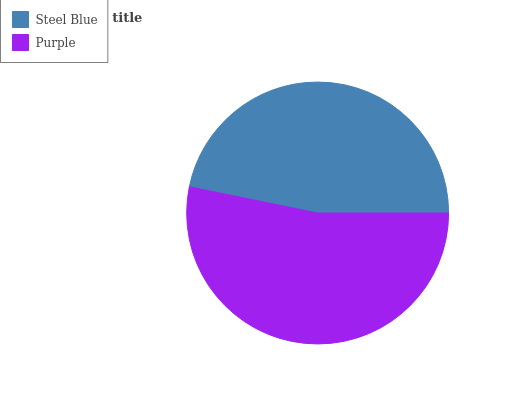Is Steel Blue the minimum?
Answer yes or no. Yes. Is Purple the maximum?
Answer yes or no. Yes. Is Purple the minimum?
Answer yes or no. No. Is Purple greater than Steel Blue?
Answer yes or no. Yes. Is Steel Blue less than Purple?
Answer yes or no. Yes. Is Steel Blue greater than Purple?
Answer yes or no. No. Is Purple less than Steel Blue?
Answer yes or no. No. Is Purple the high median?
Answer yes or no. Yes. Is Steel Blue the low median?
Answer yes or no. Yes. Is Steel Blue the high median?
Answer yes or no. No. Is Purple the low median?
Answer yes or no. No. 